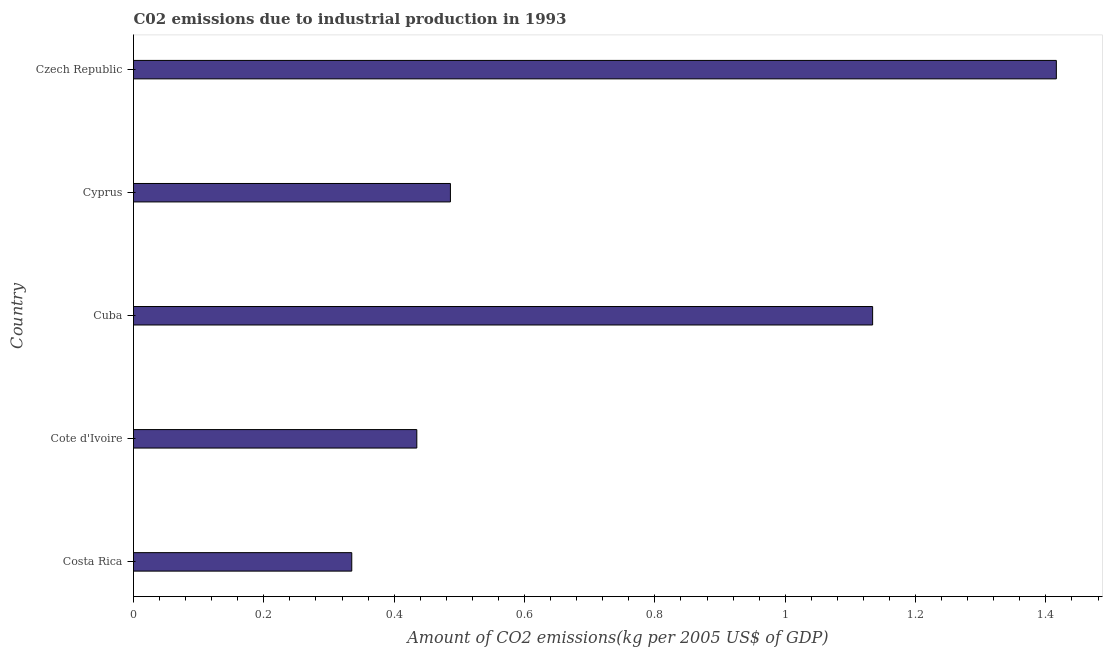Does the graph contain grids?
Your answer should be compact. No. What is the title of the graph?
Your answer should be compact. C02 emissions due to industrial production in 1993. What is the label or title of the X-axis?
Provide a succinct answer. Amount of CO2 emissions(kg per 2005 US$ of GDP). What is the amount of co2 emissions in Czech Republic?
Provide a succinct answer. 1.42. Across all countries, what is the maximum amount of co2 emissions?
Your response must be concise. 1.42. Across all countries, what is the minimum amount of co2 emissions?
Provide a short and direct response. 0.33. In which country was the amount of co2 emissions maximum?
Provide a succinct answer. Czech Republic. In which country was the amount of co2 emissions minimum?
Your answer should be compact. Costa Rica. What is the sum of the amount of co2 emissions?
Your answer should be very brief. 3.81. What is the difference between the amount of co2 emissions in Cuba and Cyprus?
Your response must be concise. 0.65. What is the average amount of co2 emissions per country?
Ensure brevity in your answer.  0.76. What is the median amount of co2 emissions?
Your answer should be very brief. 0.49. In how many countries, is the amount of co2 emissions greater than 1.12 kg per 2005 US$ of GDP?
Offer a very short reply. 2. What is the ratio of the amount of co2 emissions in Cuba to that in Czech Republic?
Your answer should be very brief. 0.8. Is the difference between the amount of co2 emissions in Cuba and Cyprus greater than the difference between any two countries?
Offer a very short reply. No. What is the difference between the highest and the second highest amount of co2 emissions?
Ensure brevity in your answer.  0.28. How many bars are there?
Ensure brevity in your answer.  5. Are all the bars in the graph horizontal?
Ensure brevity in your answer.  Yes. How many countries are there in the graph?
Your answer should be very brief. 5. What is the difference between two consecutive major ticks on the X-axis?
Make the answer very short. 0.2. What is the Amount of CO2 emissions(kg per 2005 US$ of GDP) of Costa Rica?
Provide a succinct answer. 0.33. What is the Amount of CO2 emissions(kg per 2005 US$ of GDP) of Cote d'Ivoire?
Offer a terse response. 0.43. What is the Amount of CO2 emissions(kg per 2005 US$ of GDP) in Cuba?
Provide a succinct answer. 1.13. What is the Amount of CO2 emissions(kg per 2005 US$ of GDP) of Cyprus?
Provide a short and direct response. 0.49. What is the Amount of CO2 emissions(kg per 2005 US$ of GDP) in Czech Republic?
Your answer should be very brief. 1.42. What is the difference between the Amount of CO2 emissions(kg per 2005 US$ of GDP) in Costa Rica and Cote d'Ivoire?
Provide a short and direct response. -0.1. What is the difference between the Amount of CO2 emissions(kg per 2005 US$ of GDP) in Costa Rica and Cuba?
Your response must be concise. -0.8. What is the difference between the Amount of CO2 emissions(kg per 2005 US$ of GDP) in Costa Rica and Cyprus?
Provide a succinct answer. -0.15. What is the difference between the Amount of CO2 emissions(kg per 2005 US$ of GDP) in Costa Rica and Czech Republic?
Make the answer very short. -1.08. What is the difference between the Amount of CO2 emissions(kg per 2005 US$ of GDP) in Cote d'Ivoire and Cuba?
Keep it short and to the point. -0.7. What is the difference between the Amount of CO2 emissions(kg per 2005 US$ of GDP) in Cote d'Ivoire and Cyprus?
Keep it short and to the point. -0.05. What is the difference between the Amount of CO2 emissions(kg per 2005 US$ of GDP) in Cote d'Ivoire and Czech Republic?
Your response must be concise. -0.98. What is the difference between the Amount of CO2 emissions(kg per 2005 US$ of GDP) in Cuba and Cyprus?
Offer a very short reply. 0.65. What is the difference between the Amount of CO2 emissions(kg per 2005 US$ of GDP) in Cuba and Czech Republic?
Your response must be concise. -0.28. What is the difference between the Amount of CO2 emissions(kg per 2005 US$ of GDP) in Cyprus and Czech Republic?
Make the answer very short. -0.93. What is the ratio of the Amount of CO2 emissions(kg per 2005 US$ of GDP) in Costa Rica to that in Cote d'Ivoire?
Offer a very short reply. 0.77. What is the ratio of the Amount of CO2 emissions(kg per 2005 US$ of GDP) in Costa Rica to that in Cuba?
Offer a terse response. 0.29. What is the ratio of the Amount of CO2 emissions(kg per 2005 US$ of GDP) in Costa Rica to that in Cyprus?
Offer a terse response. 0.69. What is the ratio of the Amount of CO2 emissions(kg per 2005 US$ of GDP) in Costa Rica to that in Czech Republic?
Provide a short and direct response. 0.24. What is the ratio of the Amount of CO2 emissions(kg per 2005 US$ of GDP) in Cote d'Ivoire to that in Cuba?
Give a very brief answer. 0.38. What is the ratio of the Amount of CO2 emissions(kg per 2005 US$ of GDP) in Cote d'Ivoire to that in Cyprus?
Keep it short and to the point. 0.89. What is the ratio of the Amount of CO2 emissions(kg per 2005 US$ of GDP) in Cote d'Ivoire to that in Czech Republic?
Provide a short and direct response. 0.31. What is the ratio of the Amount of CO2 emissions(kg per 2005 US$ of GDP) in Cuba to that in Cyprus?
Offer a very short reply. 2.33. What is the ratio of the Amount of CO2 emissions(kg per 2005 US$ of GDP) in Cuba to that in Czech Republic?
Make the answer very short. 0.8. What is the ratio of the Amount of CO2 emissions(kg per 2005 US$ of GDP) in Cyprus to that in Czech Republic?
Make the answer very short. 0.34. 